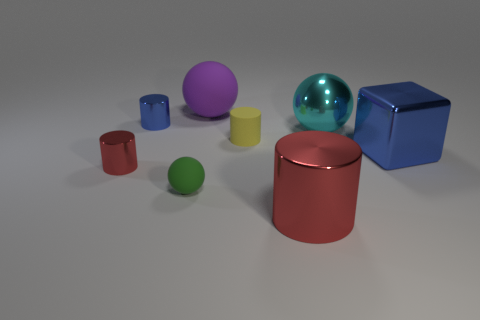Subtract all rubber balls. How many balls are left? 1 Subtract all purple cubes. How many red cylinders are left? 2 Subtract all yellow cylinders. How many cylinders are left? 3 Add 2 big yellow rubber balls. How many objects exist? 10 Subtract all cubes. How many objects are left? 7 Subtract all purple cylinders. Subtract all yellow spheres. How many cylinders are left? 4 Add 2 yellow matte cubes. How many yellow matte cubes exist? 2 Subtract 1 blue blocks. How many objects are left? 7 Subtract all large gray things. Subtract all small red cylinders. How many objects are left? 7 Add 3 red objects. How many red objects are left? 5 